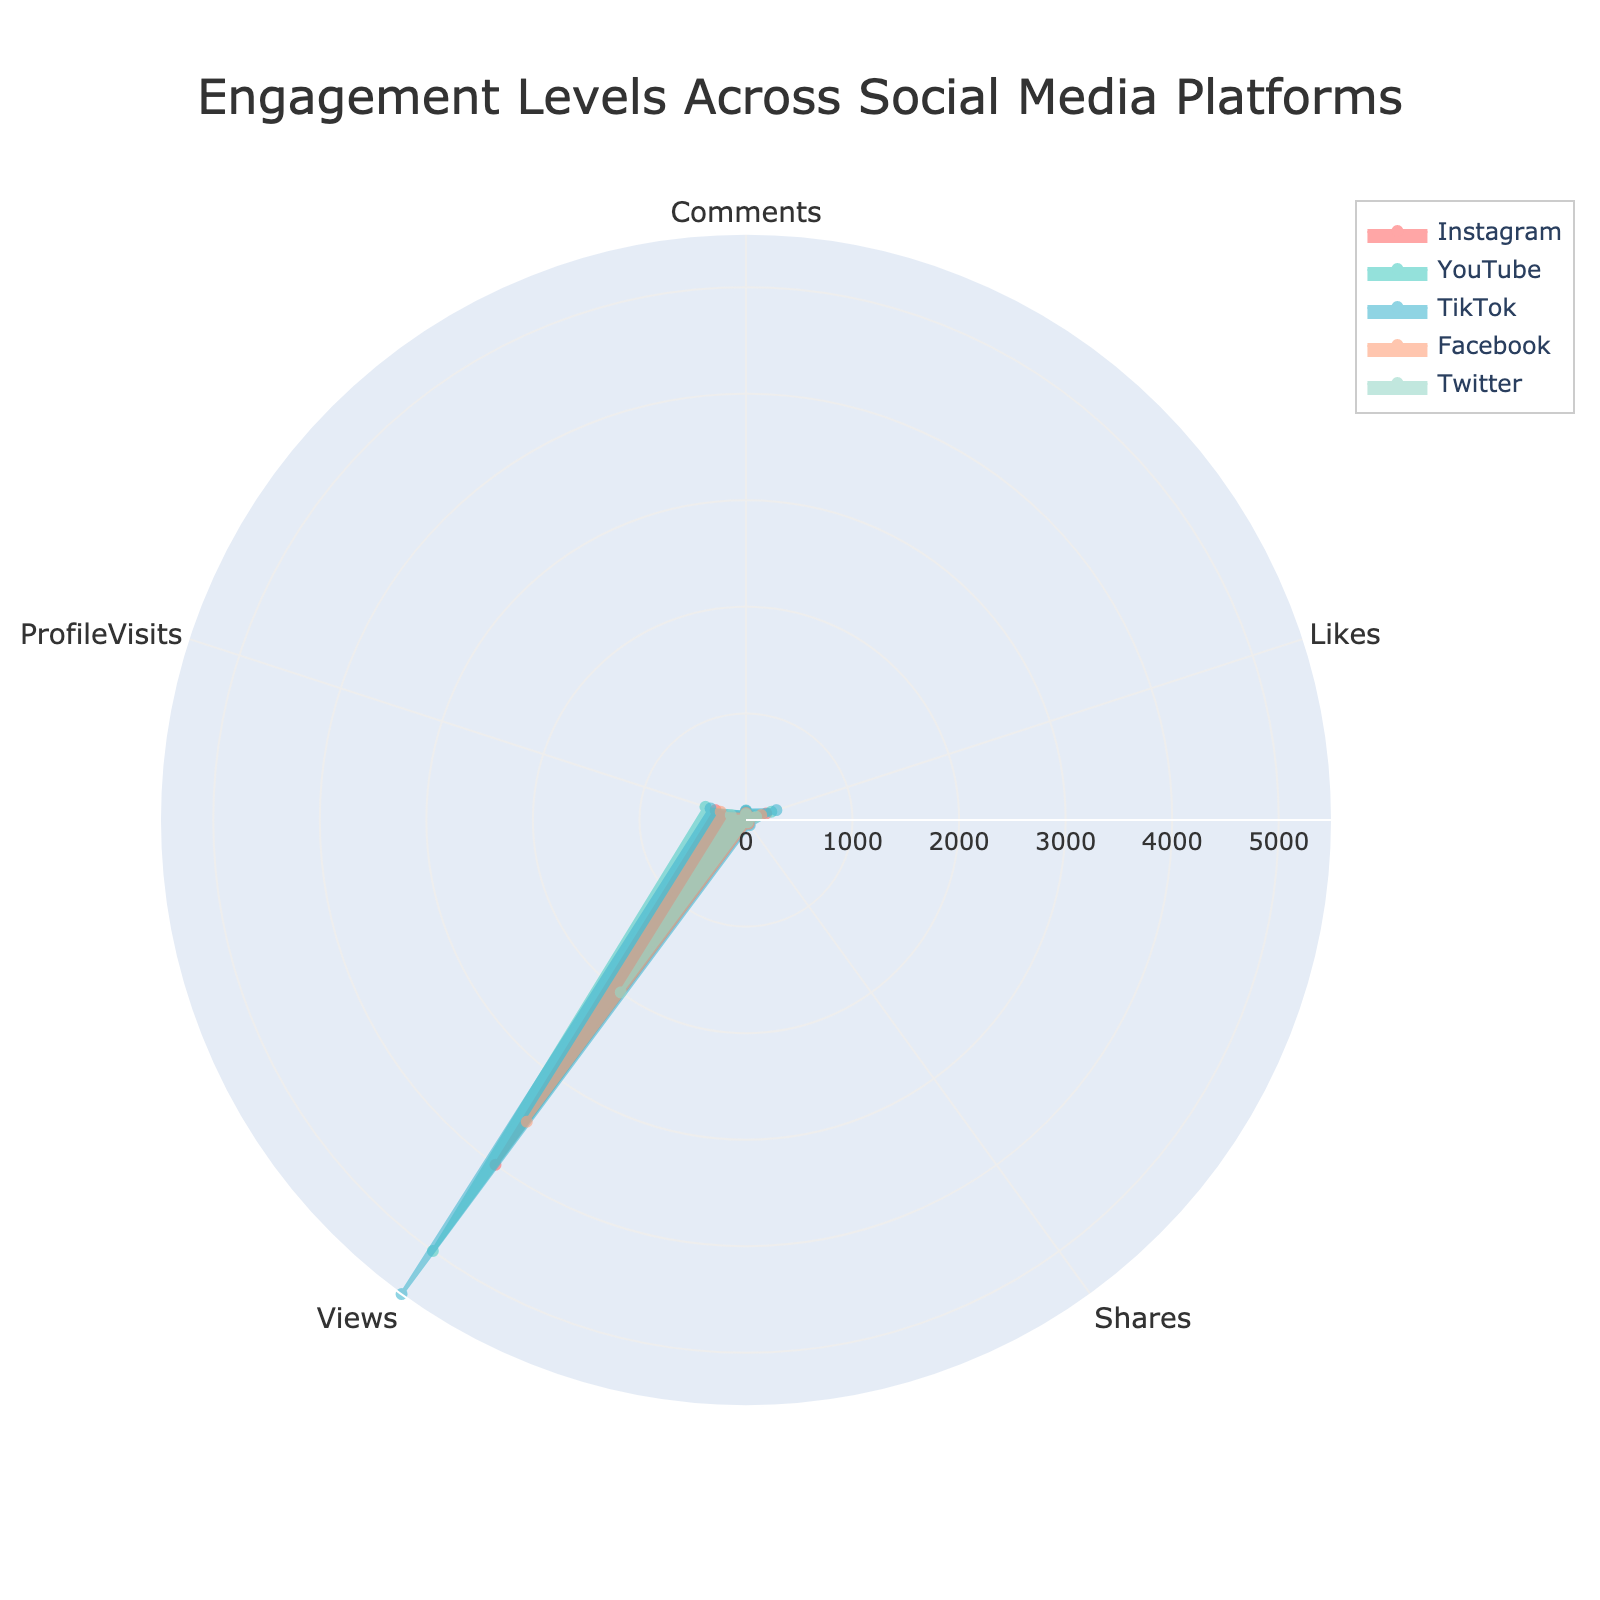Which platform has the highest number of profile visits? The platform with the highest number of profile visits is the one with the largest value on the ProfileVisits axis.
Answer: YouTube Which social media platform received the least number of comments? Look at the Comments axis and identify the platform with the lowest value.
Answer: Twitter How many platforms have more than 50 shares? Check the values along the Shares axis and count the platforms with values exceeding 50.
Answer: Two What is the difference in profile visits between Facebook and Twitter? Find the values for profile visits for both Facebook and Twitter and subtract Twitter's value from Facebook's value: 250 - 150 = 100.
Answer: 100 Which platform has the lowest view count? Identify the platform with the smallest value on the Views axis.
Answer: Twitter Rank the platforms based on the number of likes from highest to lowest. Arrange the platforms by their Likes values in descending order: TikTok, YouTube, Instagram, Facebook, Twitter.
Answer: TikTok, YouTube, Instagram, Facebook, Twitter Which two platforms have nearly equal comments? Compare the values along the Comments axis and find the two platforms with the closest values.
Answer: Instagram and YouTube What is the total number of shares for all platforms combined? Add up the share counts from each platform: 45 (Instagram) + 30 (YouTube) + 60 (TikTok) + 40 (Facebook) + 25 (Twitter) = 200.
Answer: 200 Which platform shows the most balanced engagement across all categories? Look at all the axes and judge which platform's values are most evenly spread out.
Answer: TikTok What is the average number of likes received across all five platforms? Add up the likes for all platforms and divide by the number of platforms: (200 + 250 + 300 + 150 + 100) / 5 = 1000 / 5 = 200.
Answer: 200 